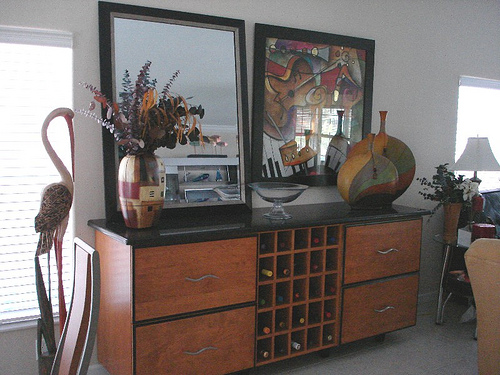<image>
Is the mirror behind the frame? No. The mirror is not behind the frame. From this viewpoint, the mirror appears to be positioned elsewhere in the scene. Is there a lamp on the floor? No. The lamp is not positioned on the floor. They may be near each other, but the lamp is not supported by or resting on top of the floor. 